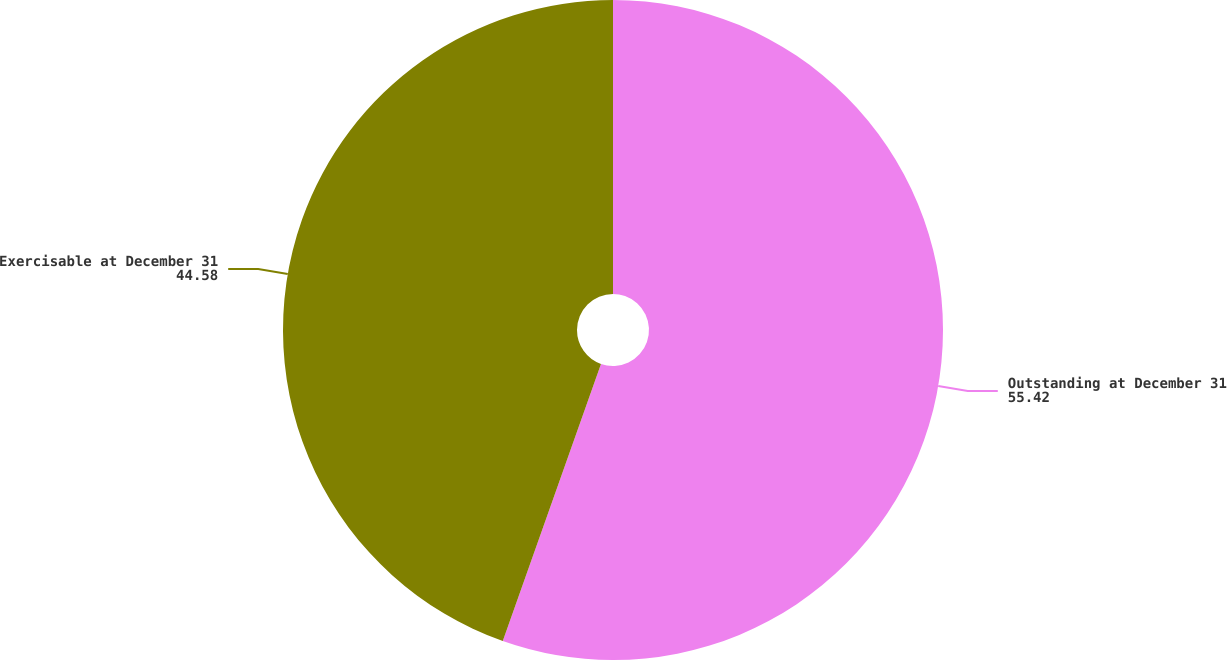Convert chart. <chart><loc_0><loc_0><loc_500><loc_500><pie_chart><fcel>Outstanding at December 31<fcel>Exercisable at December 31<nl><fcel>55.42%<fcel>44.58%<nl></chart> 